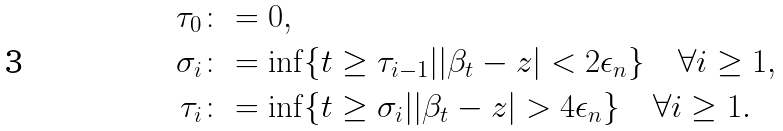Convert formula to latex. <formula><loc_0><loc_0><loc_500><loc_500>\tau _ { 0 } & \colon = 0 , \\ \sigma _ { i } & \colon = \inf \{ t \geq \tau _ { i - 1 } | | \beta _ { t } - z | < 2 \epsilon _ { n } \} \quad \forall i \geq 1 , \\ \tau _ { i } & \colon = \inf \{ t \geq \sigma _ { i } | | \beta _ { t } - z | > 4 \epsilon _ { n } \} \quad \forall i \geq 1 .</formula> 